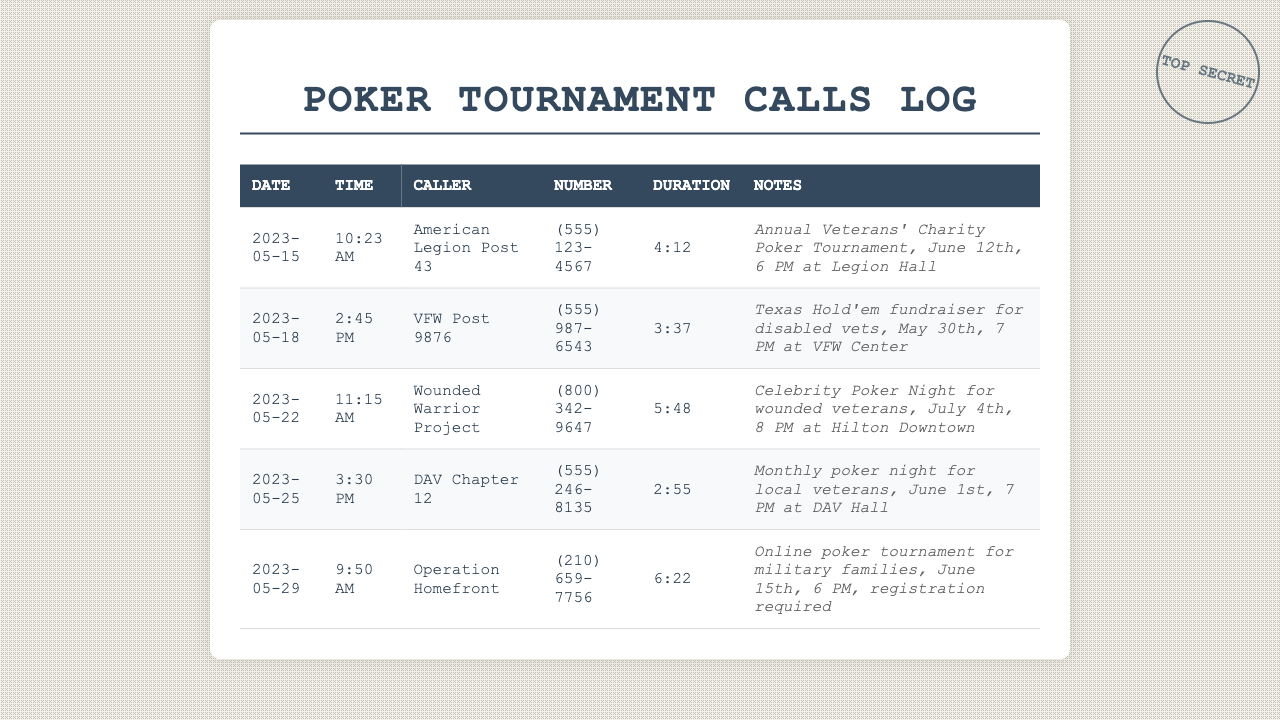What is the date of the call from the American Legion Post 43? The call from the American Legion Post 43 occurred on May 15, 2023.
Answer: May 15, 2023 How long did the call from VFW Post 9876 last? The duration of the call from VFW Post 9876 was 3 minutes and 37 seconds.
Answer: 3:37 What event is being held by the Wounded Warrior Project? The Wounded Warrior Project is hosting a Celebrity Poker Night for wounded veterans.
Answer: Celebrity Poker Night When is the poker tournament hosted by DAV Chapter 12? The poker tournament hosted by DAV Chapter 12 is scheduled for June 1st at 7 PM.
Answer: June 1st Which organization is hosting an online poker tournament? Operation Homefront is organizing the online poker tournament for military families.
Answer: Operation Homefront What time is the Texas Hold'em fundraiser set to begin? The Texas Hold'em fundraiser is set to begin at 7 PM.
Answer: 7 PM How many calls were made regarding poker tournaments? There are five calls recorded regarding poker tournaments in the document.
Answer: Five What is the phone number for the American Legion Post 43? The phone number for the American Legion Post 43 is (555) 123-4567.
Answer: (555) 123-4567 What is the overall purpose of the calls recorded in this document? The overall purpose of the calls is to invite participation in charity poker tournaments.
Answer: Charity poker tournaments 